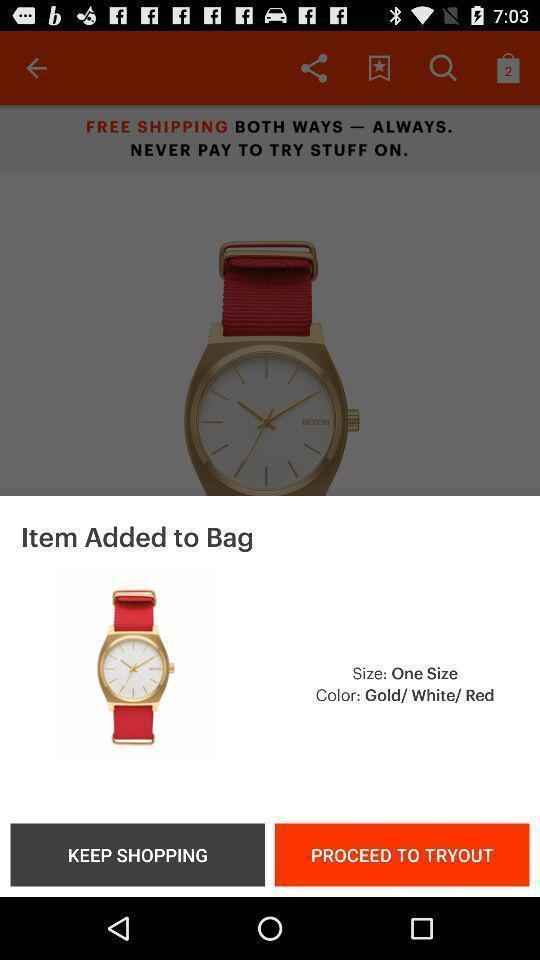Describe the content in this image. Popup page of adding item to bag of shopping app. 